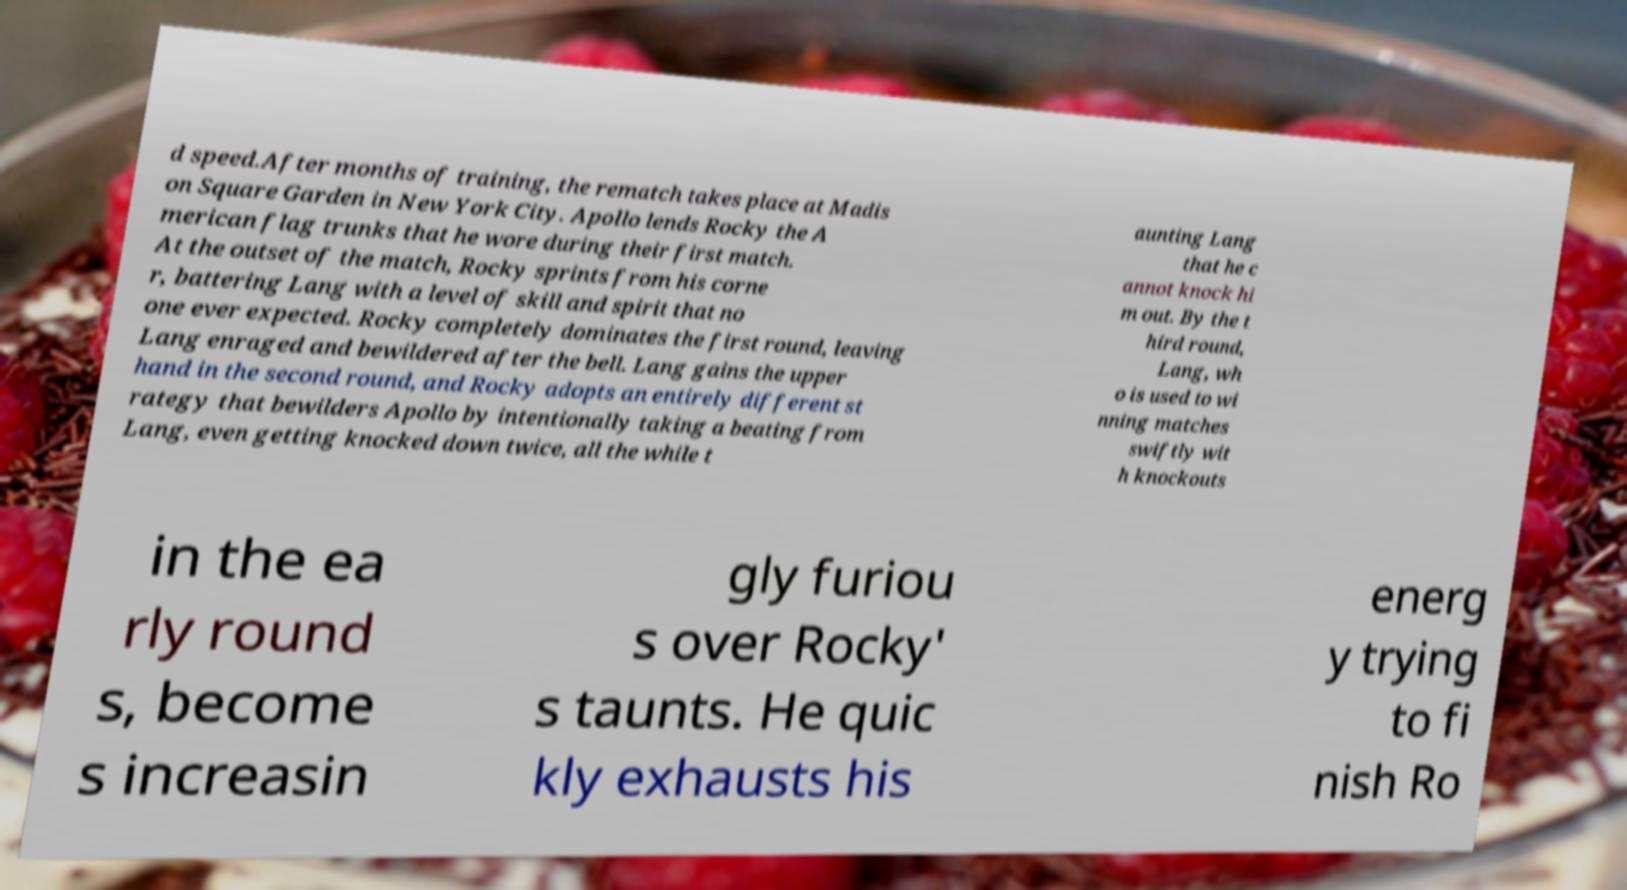For documentation purposes, I need the text within this image transcribed. Could you provide that? d speed.After months of training, the rematch takes place at Madis on Square Garden in New York City. Apollo lends Rocky the A merican flag trunks that he wore during their first match. At the outset of the match, Rocky sprints from his corne r, battering Lang with a level of skill and spirit that no one ever expected. Rocky completely dominates the first round, leaving Lang enraged and bewildered after the bell. Lang gains the upper hand in the second round, and Rocky adopts an entirely different st rategy that bewilders Apollo by intentionally taking a beating from Lang, even getting knocked down twice, all the while t aunting Lang that he c annot knock hi m out. By the t hird round, Lang, wh o is used to wi nning matches swiftly wit h knockouts in the ea rly round s, become s increasin gly furiou s over Rocky' s taunts. He quic kly exhausts his energ y trying to fi nish Ro 